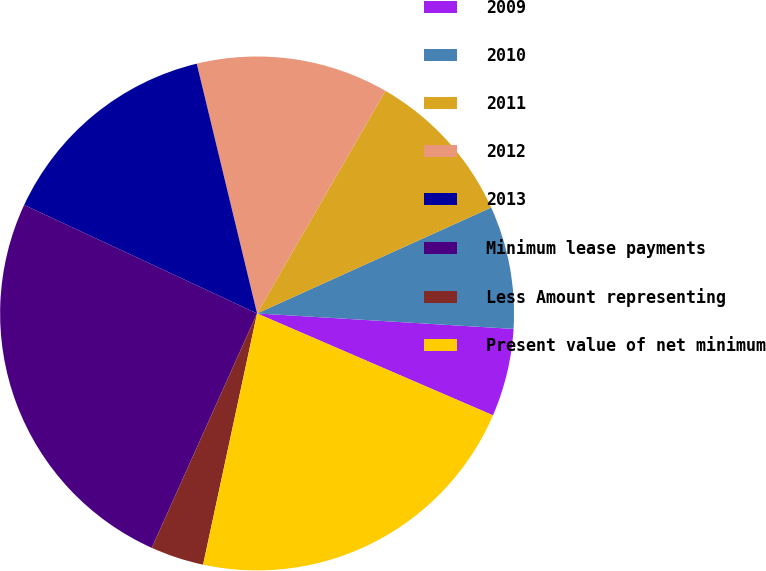Convert chart. <chart><loc_0><loc_0><loc_500><loc_500><pie_chart><fcel>2009<fcel>2010<fcel>2011<fcel>2012<fcel>2013<fcel>Minimum lease payments<fcel>Less Amount representing<fcel>Present value of net minimum<nl><fcel>5.53%<fcel>7.72%<fcel>9.91%<fcel>12.1%<fcel>14.29%<fcel>25.22%<fcel>3.35%<fcel>21.88%<nl></chart> 